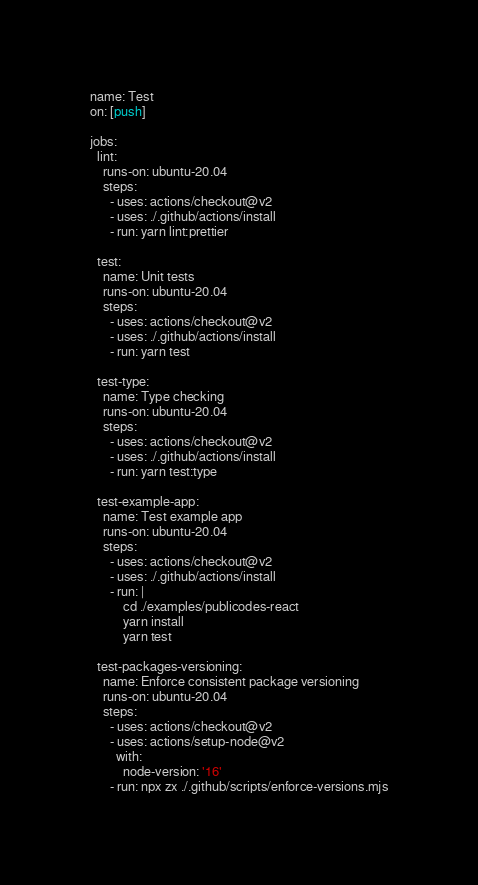Convert code to text. <code><loc_0><loc_0><loc_500><loc_500><_YAML_>name: Test
on: [push]

jobs:
  lint:
    runs-on: ubuntu-20.04
    steps:
      - uses: actions/checkout@v2
      - uses: ./.github/actions/install
      - run: yarn lint:prettier

  test:
    name: Unit tests
    runs-on: ubuntu-20.04
    steps:
      - uses: actions/checkout@v2
      - uses: ./.github/actions/install
      - run: yarn test

  test-type:
    name: Type checking
    runs-on: ubuntu-20.04
    steps:
      - uses: actions/checkout@v2
      - uses: ./.github/actions/install
      - run: yarn test:type

  test-example-app:
    name: Test example app
    runs-on: ubuntu-20.04
    steps:
      - uses: actions/checkout@v2
      - uses: ./.github/actions/install
      - run: |
          cd ./examples/publicodes-react
          yarn install
          yarn test

  test-packages-versioning:
    name: Enforce consistent package versioning
    runs-on: ubuntu-20.04
    steps:
      - uses: actions/checkout@v2
      - uses: actions/setup-node@v2
        with:
          node-version: '16'
      - run: npx zx ./.github/scripts/enforce-versions.mjs
</code> 